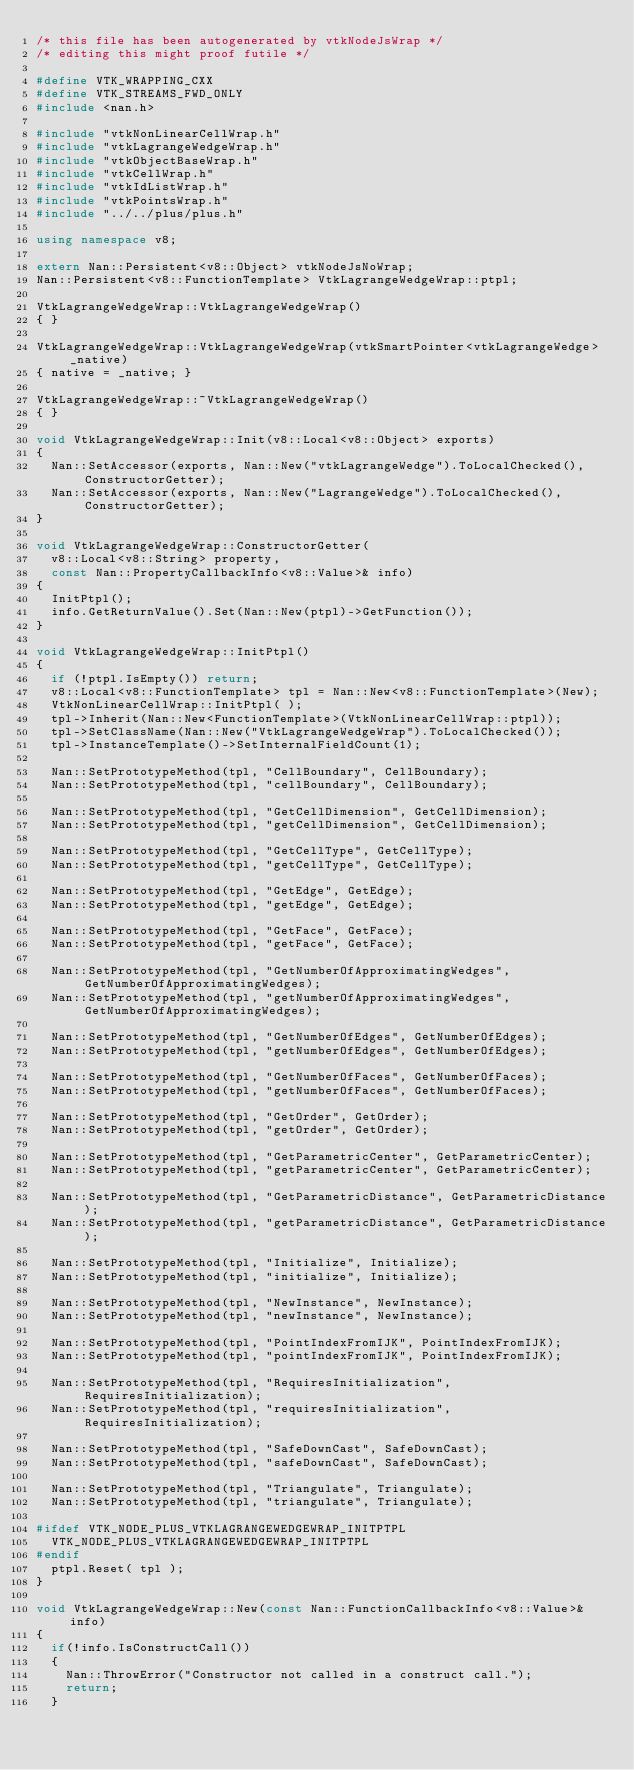Convert code to text. <code><loc_0><loc_0><loc_500><loc_500><_C++_>/* this file has been autogenerated by vtkNodeJsWrap */
/* editing this might proof futile */

#define VTK_WRAPPING_CXX
#define VTK_STREAMS_FWD_ONLY
#include <nan.h>

#include "vtkNonLinearCellWrap.h"
#include "vtkLagrangeWedgeWrap.h"
#include "vtkObjectBaseWrap.h"
#include "vtkCellWrap.h"
#include "vtkIdListWrap.h"
#include "vtkPointsWrap.h"
#include "../../plus/plus.h"

using namespace v8;

extern Nan::Persistent<v8::Object> vtkNodeJsNoWrap;
Nan::Persistent<v8::FunctionTemplate> VtkLagrangeWedgeWrap::ptpl;

VtkLagrangeWedgeWrap::VtkLagrangeWedgeWrap()
{ }

VtkLagrangeWedgeWrap::VtkLagrangeWedgeWrap(vtkSmartPointer<vtkLagrangeWedge> _native)
{ native = _native; }

VtkLagrangeWedgeWrap::~VtkLagrangeWedgeWrap()
{ }

void VtkLagrangeWedgeWrap::Init(v8::Local<v8::Object> exports)
{
	Nan::SetAccessor(exports, Nan::New("vtkLagrangeWedge").ToLocalChecked(), ConstructorGetter);
	Nan::SetAccessor(exports, Nan::New("LagrangeWedge").ToLocalChecked(), ConstructorGetter);
}

void VtkLagrangeWedgeWrap::ConstructorGetter(
	v8::Local<v8::String> property,
	const Nan::PropertyCallbackInfo<v8::Value>& info)
{
	InitPtpl();
	info.GetReturnValue().Set(Nan::New(ptpl)->GetFunction());
}

void VtkLagrangeWedgeWrap::InitPtpl()
{
	if (!ptpl.IsEmpty()) return;
	v8::Local<v8::FunctionTemplate> tpl = Nan::New<v8::FunctionTemplate>(New);
	VtkNonLinearCellWrap::InitPtpl( );
	tpl->Inherit(Nan::New<FunctionTemplate>(VtkNonLinearCellWrap::ptpl));
	tpl->SetClassName(Nan::New("VtkLagrangeWedgeWrap").ToLocalChecked());
	tpl->InstanceTemplate()->SetInternalFieldCount(1);

	Nan::SetPrototypeMethod(tpl, "CellBoundary", CellBoundary);
	Nan::SetPrototypeMethod(tpl, "cellBoundary", CellBoundary);

	Nan::SetPrototypeMethod(tpl, "GetCellDimension", GetCellDimension);
	Nan::SetPrototypeMethod(tpl, "getCellDimension", GetCellDimension);

	Nan::SetPrototypeMethod(tpl, "GetCellType", GetCellType);
	Nan::SetPrototypeMethod(tpl, "getCellType", GetCellType);

	Nan::SetPrototypeMethod(tpl, "GetEdge", GetEdge);
	Nan::SetPrototypeMethod(tpl, "getEdge", GetEdge);

	Nan::SetPrototypeMethod(tpl, "GetFace", GetFace);
	Nan::SetPrototypeMethod(tpl, "getFace", GetFace);

	Nan::SetPrototypeMethod(tpl, "GetNumberOfApproximatingWedges", GetNumberOfApproximatingWedges);
	Nan::SetPrototypeMethod(tpl, "getNumberOfApproximatingWedges", GetNumberOfApproximatingWedges);

	Nan::SetPrototypeMethod(tpl, "GetNumberOfEdges", GetNumberOfEdges);
	Nan::SetPrototypeMethod(tpl, "getNumberOfEdges", GetNumberOfEdges);

	Nan::SetPrototypeMethod(tpl, "GetNumberOfFaces", GetNumberOfFaces);
	Nan::SetPrototypeMethod(tpl, "getNumberOfFaces", GetNumberOfFaces);

	Nan::SetPrototypeMethod(tpl, "GetOrder", GetOrder);
	Nan::SetPrototypeMethod(tpl, "getOrder", GetOrder);

	Nan::SetPrototypeMethod(tpl, "GetParametricCenter", GetParametricCenter);
	Nan::SetPrototypeMethod(tpl, "getParametricCenter", GetParametricCenter);

	Nan::SetPrototypeMethod(tpl, "GetParametricDistance", GetParametricDistance);
	Nan::SetPrototypeMethod(tpl, "getParametricDistance", GetParametricDistance);

	Nan::SetPrototypeMethod(tpl, "Initialize", Initialize);
	Nan::SetPrototypeMethod(tpl, "initialize", Initialize);

	Nan::SetPrototypeMethod(tpl, "NewInstance", NewInstance);
	Nan::SetPrototypeMethod(tpl, "newInstance", NewInstance);

	Nan::SetPrototypeMethod(tpl, "PointIndexFromIJK", PointIndexFromIJK);
	Nan::SetPrototypeMethod(tpl, "pointIndexFromIJK", PointIndexFromIJK);

	Nan::SetPrototypeMethod(tpl, "RequiresInitialization", RequiresInitialization);
	Nan::SetPrototypeMethod(tpl, "requiresInitialization", RequiresInitialization);

	Nan::SetPrototypeMethod(tpl, "SafeDownCast", SafeDownCast);
	Nan::SetPrototypeMethod(tpl, "safeDownCast", SafeDownCast);

	Nan::SetPrototypeMethod(tpl, "Triangulate", Triangulate);
	Nan::SetPrototypeMethod(tpl, "triangulate", Triangulate);

#ifdef VTK_NODE_PLUS_VTKLAGRANGEWEDGEWRAP_INITPTPL
	VTK_NODE_PLUS_VTKLAGRANGEWEDGEWRAP_INITPTPL
#endif
	ptpl.Reset( tpl );
}

void VtkLagrangeWedgeWrap::New(const Nan::FunctionCallbackInfo<v8::Value>& info)
{
	if(!info.IsConstructCall())
	{
		Nan::ThrowError("Constructor not called in a construct call.");
		return;
	}
</code> 